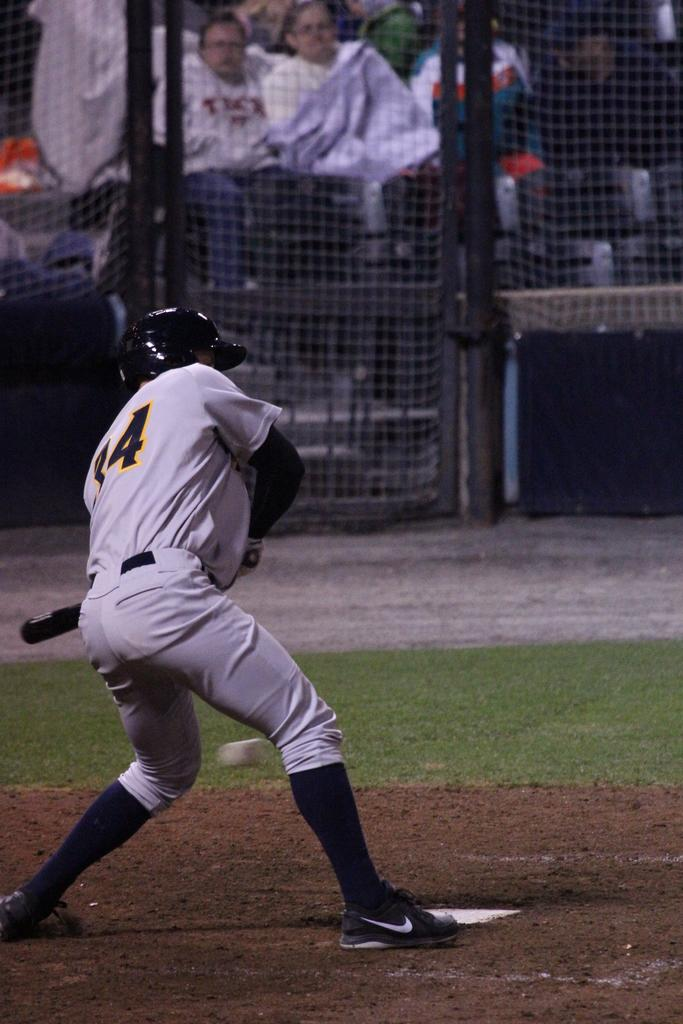<image>
Create a compact narrative representing the image presented. Baseball player wearing number 34 about to bat. 